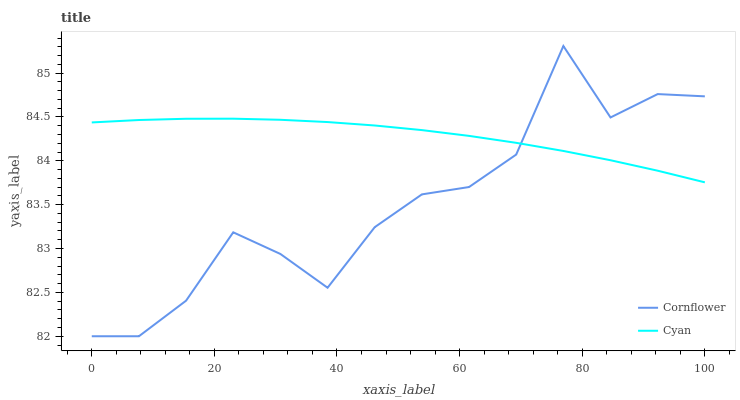Does Cornflower have the minimum area under the curve?
Answer yes or no. Yes. Does Cyan have the maximum area under the curve?
Answer yes or no. Yes. Does Cyan have the minimum area under the curve?
Answer yes or no. No. Is Cyan the smoothest?
Answer yes or no. Yes. Is Cornflower the roughest?
Answer yes or no. Yes. Is Cyan the roughest?
Answer yes or no. No. Does Cyan have the lowest value?
Answer yes or no. No. Does Cornflower have the highest value?
Answer yes or no. Yes. Does Cyan have the highest value?
Answer yes or no. No. Does Cornflower intersect Cyan?
Answer yes or no. Yes. Is Cornflower less than Cyan?
Answer yes or no. No. Is Cornflower greater than Cyan?
Answer yes or no. No. 